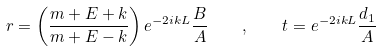Convert formula to latex. <formula><loc_0><loc_0><loc_500><loc_500>r = \left ( \frac { m + E + k } { m + E - k } \right ) e ^ { - 2 i k L } \frac { B } { A } \quad , \quad t = e ^ { - 2 i k L } \frac { d _ { 1 } } { A }</formula> 